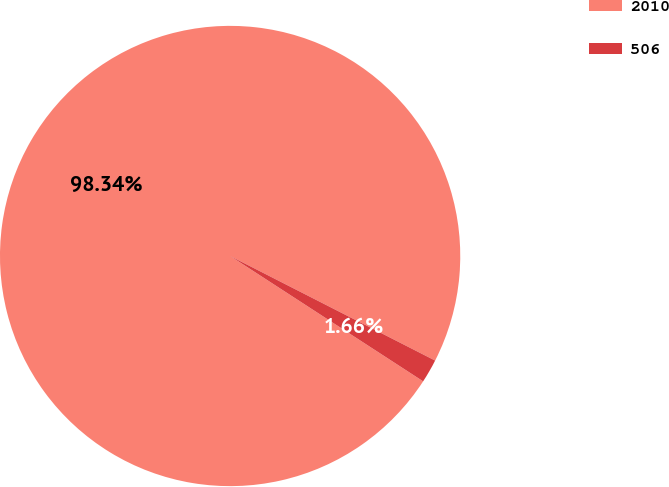Convert chart to OTSL. <chart><loc_0><loc_0><loc_500><loc_500><pie_chart><fcel>2010<fcel>506<nl><fcel>98.34%<fcel>1.66%<nl></chart> 